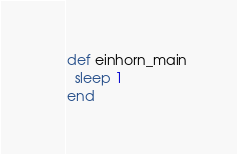<code> <loc_0><loc_0><loc_500><loc_500><_Ruby_>def einhorn_main
  sleep 1
end</code> 